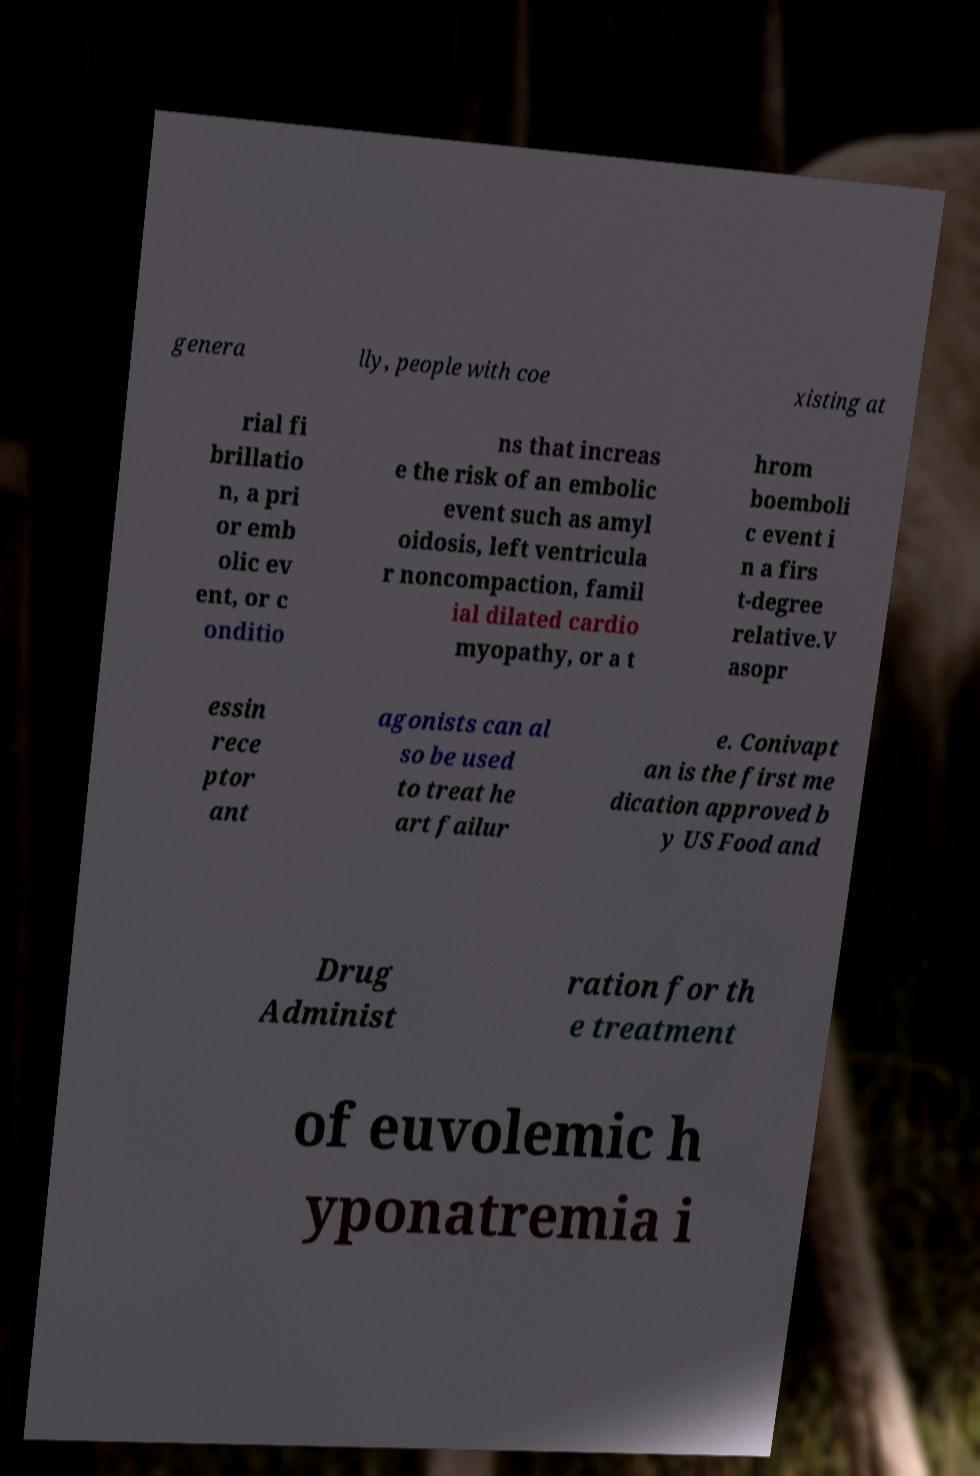For documentation purposes, I need the text within this image transcribed. Could you provide that? genera lly, people with coe xisting at rial fi brillatio n, a pri or emb olic ev ent, or c onditio ns that increas e the risk of an embolic event such as amyl oidosis, left ventricula r noncompaction, famil ial dilated cardio myopathy, or a t hrom boemboli c event i n a firs t-degree relative.V asopr essin rece ptor ant agonists can al so be used to treat he art failur e. Conivapt an is the first me dication approved b y US Food and Drug Administ ration for th e treatment of euvolemic h yponatremia i 